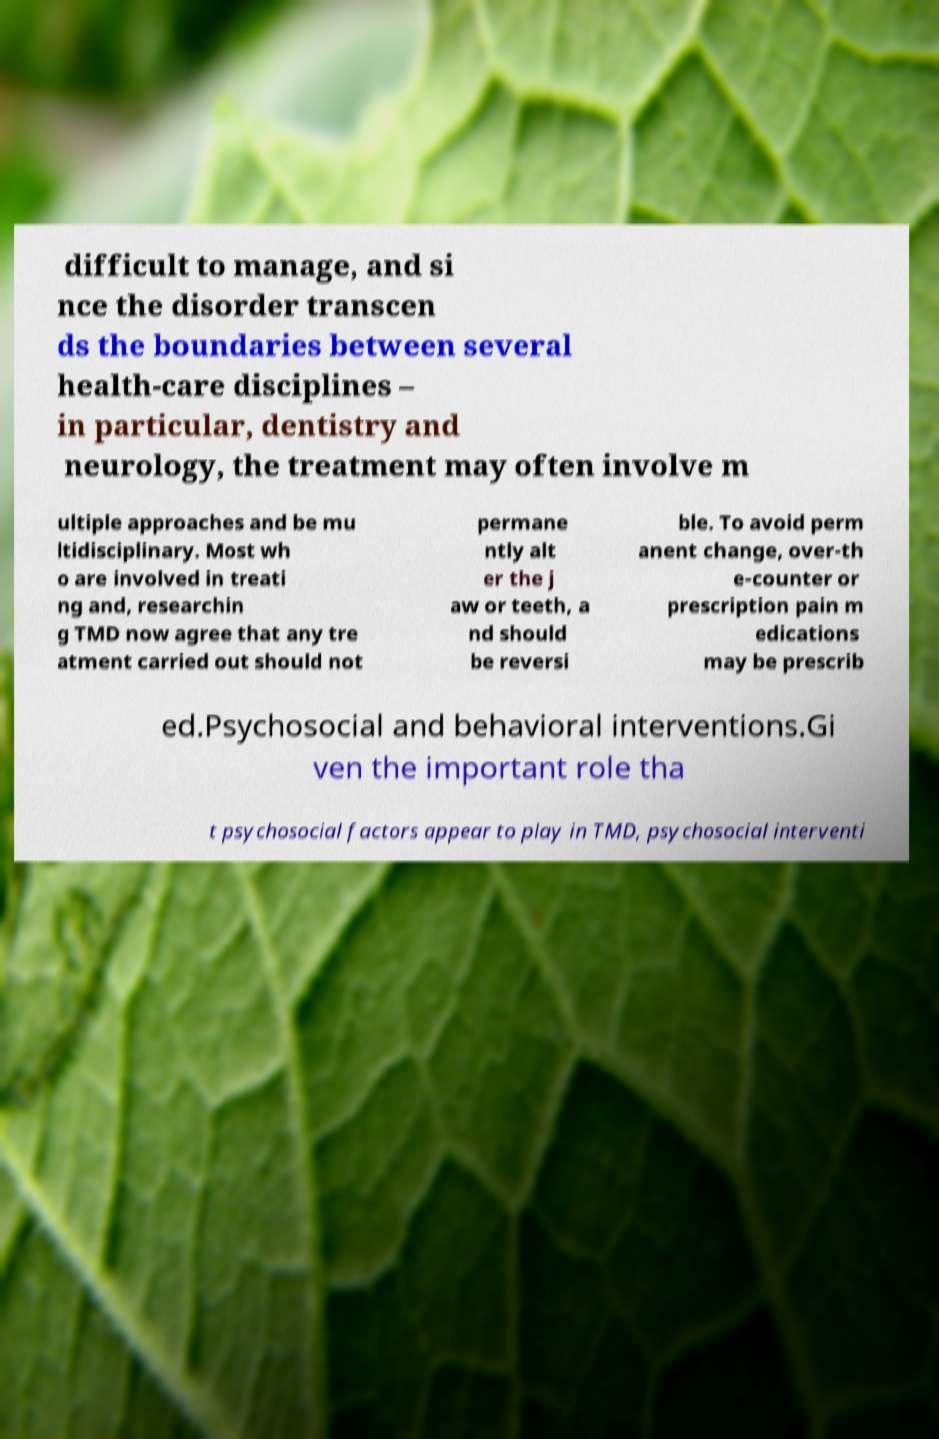Could you extract and type out the text from this image? difficult to manage, and si nce the disorder transcen ds the boundaries between several health-care disciplines – in particular, dentistry and neurology, the treatment may often involve m ultiple approaches and be mu ltidisciplinary. Most wh o are involved in treati ng and, researchin g TMD now agree that any tre atment carried out should not permane ntly alt er the j aw or teeth, a nd should be reversi ble. To avoid perm anent change, over-th e-counter or prescription pain m edications may be prescrib ed.Psychosocial and behavioral interventions.Gi ven the important role tha t psychosocial factors appear to play in TMD, psychosocial interventi 